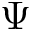<formula> <loc_0><loc_0><loc_500><loc_500>\Psi</formula> 